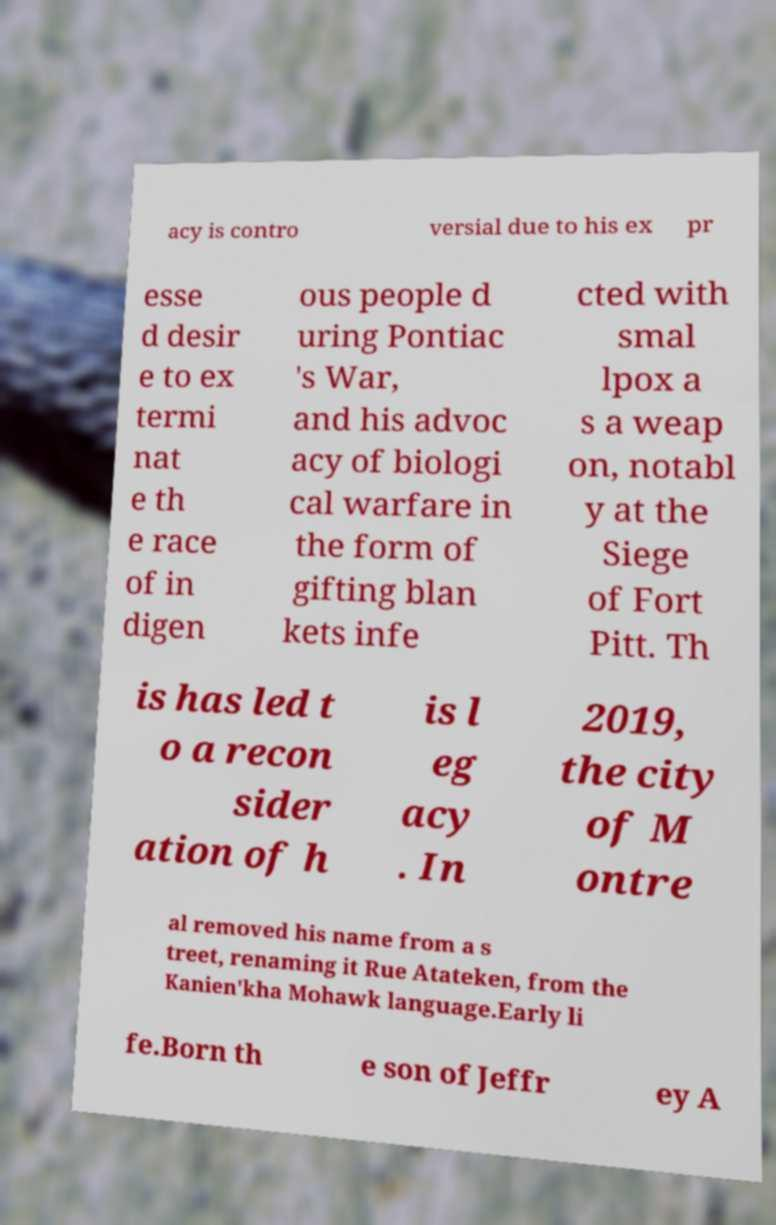What messages or text are displayed in this image? I need them in a readable, typed format. acy is contro versial due to his ex pr esse d desir e to ex termi nat e th e race of in digen ous people d uring Pontiac 's War, and his advoc acy of biologi cal warfare in the form of gifting blan kets infe cted with smal lpox a s a weap on, notabl y at the Siege of Fort Pitt. Th is has led t o a recon sider ation of h is l eg acy . In 2019, the city of M ontre al removed his name from a s treet, renaming it Rue Atateken, from the Kanien'kha Mohawk language.Early li fe.Born th e son of Jeffr ey A 